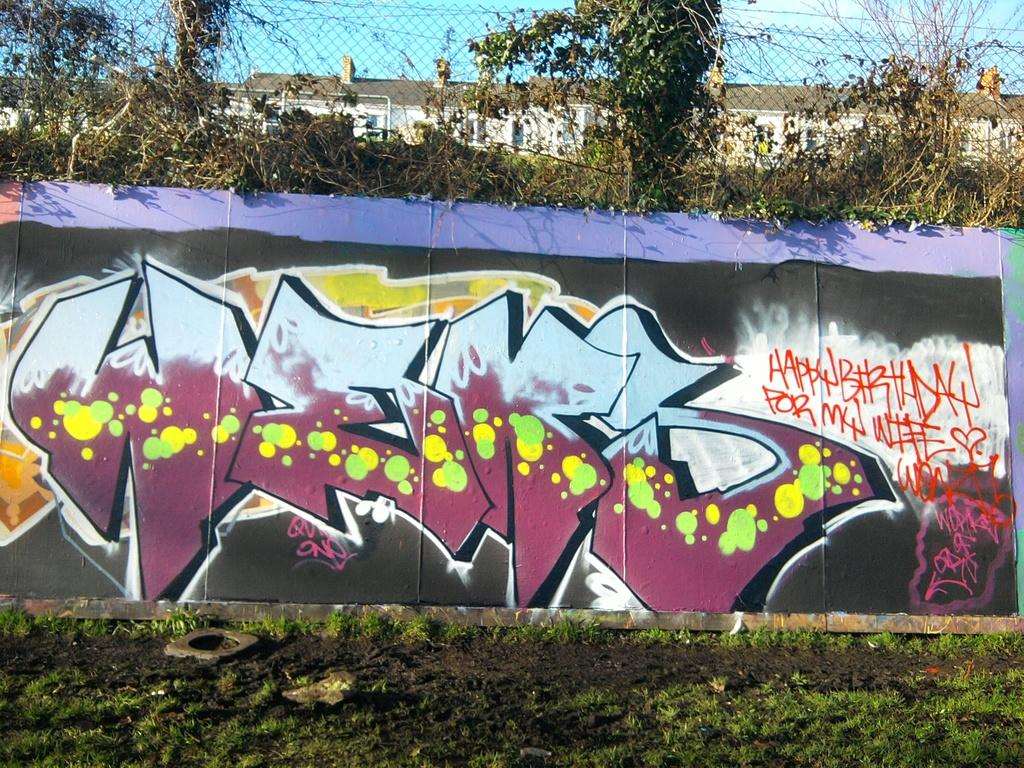What is on the wall in the image? There is graffiti on the wall in the image. What is on the ground in the image? There are plants and grass on the ground in the image. What type of structure is visible in the image? There is a building visible in the image. What is on the wall that surrounds the graffiti? There is a metal fence on the wall in the image. What color is the sky in the image? The sky is blue in the image. What color is the skin of the person in the image? There is no person present in the image, so we cannot determine the color of their skin. What color is the eye of the animal in the image? There are no animals present in the image, so we cannot determine the color of their eyes. 